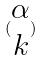Convert formula to latex. <formula><loc_0><loc_0><loc_500><loc_500>( \begin{matrix} \alpha \\ k \end{matrix} )</formula> 